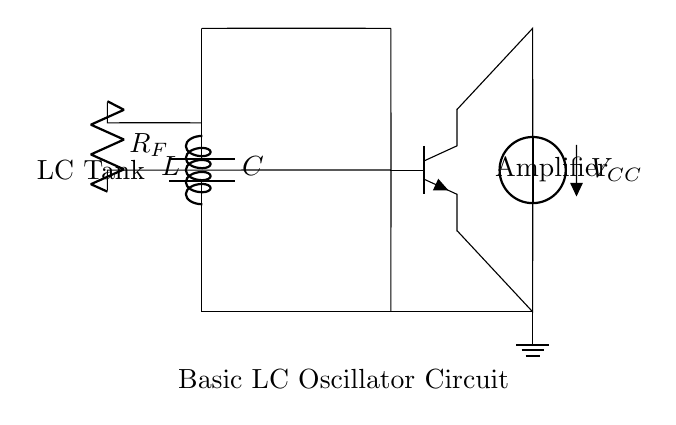What type of charge does the capacitor store? The capacitor stores electrical charge, which can be positive or negative depending on the connections but is primarily considered positive in the context of capacitors discharging current.
Answer: electrical charge What is the role of the inductor in this circuit? The inductor in an LC oscillator stores magnetic energy when a current flows through it and interacts with the electrical energy stored in the capacitor to create oscillations.
Answer: to store magnetic energy What is the purpose of the feedback resistor in this oscillator? The feedback resistor helps maintain the oscillations by providing a necessary signal to the base of the transistor, thus ensuring the circuit can sustain its operation.
Answer: sustain oscillations What does the component labeled C represent? The component labeled C represents the capacitor in the circuit. It is responsible for storing and releasing electrical energy, contributing to the oscillatory behavior of the LC circuit.
Answer: capacitor What is the name of this type of circuit? This type of circuit is called an LC oscillator, which is designed to generate oscillating signals. Through the interplay of the inductor and capacitor, it creates simple harmonic motion.
Answer: LC oscillator What happens during the oscillation cycle in this circuit? During the oscillation cycle, energy alternates between being stored in the capacitor as electric potential energy and in the inductor as magnetic potential energy, creating a continuous oscillation.
Answer: energy alternates 